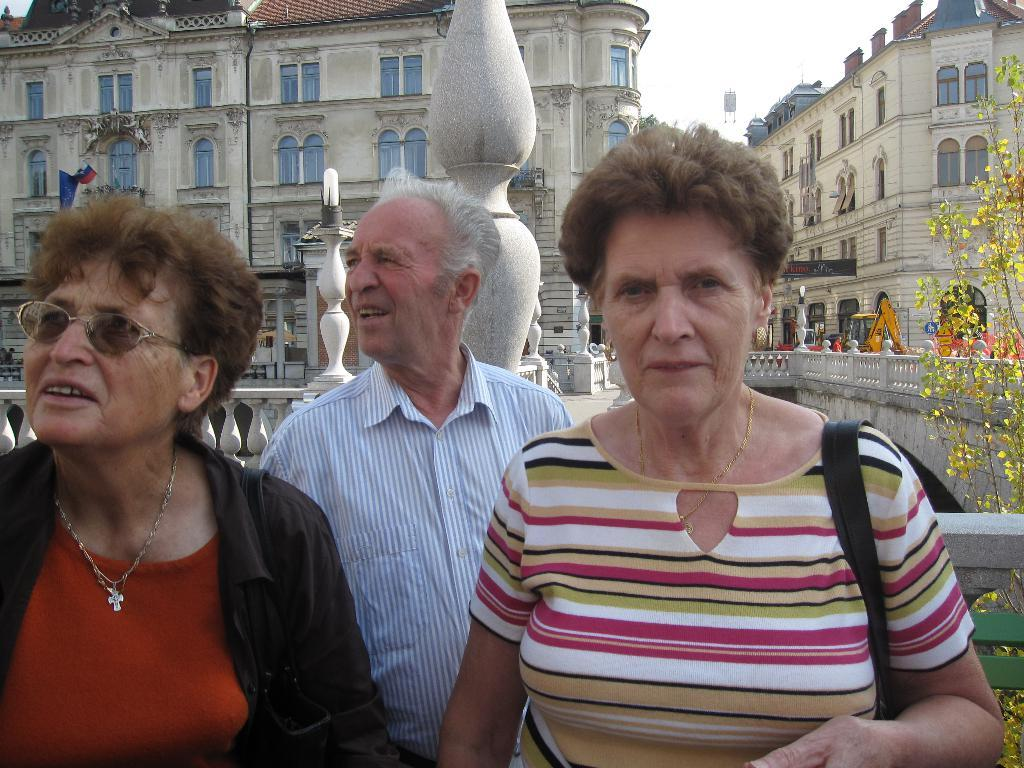How many people are present in the image? There are three persons standing in the image. What can be seen in the background of the image? There are plants and buildings in the background of the image. What is the color of the plants in the image? The plants in the image are green. What is visible in the sky in the image? The sky is visible in the image, and it is white. What type of carriage can be seen in the image? There is no carriage present in the image. What country is depicted in the scene? The image does not depict a specific country; it only shows three persons, plants, buildings, and a white sky. 